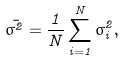Convert formula to latex. <formula><loc_0><loc_0><loc_500><loc_500>\bar { \sigma ^ { 2 } } = \frac { 1 } { N } \sum _ { i = 1 } ^ { N } \sigma _ { i } ^ { 2 } ,</formula> 